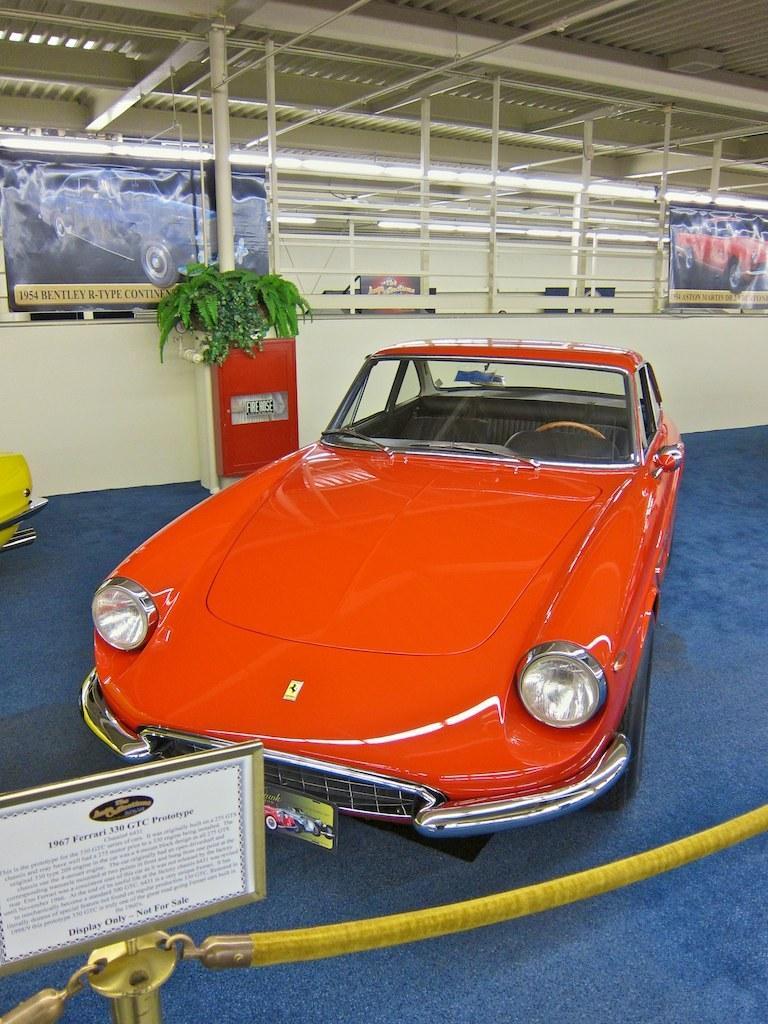Could you give a brief overview of what you see in this image? In this image in front there is a fence. There is a board. There is a car on the mat. In the background of the image there is a flower pot. There are banners. On top of the image there are lights. There is a wall. 